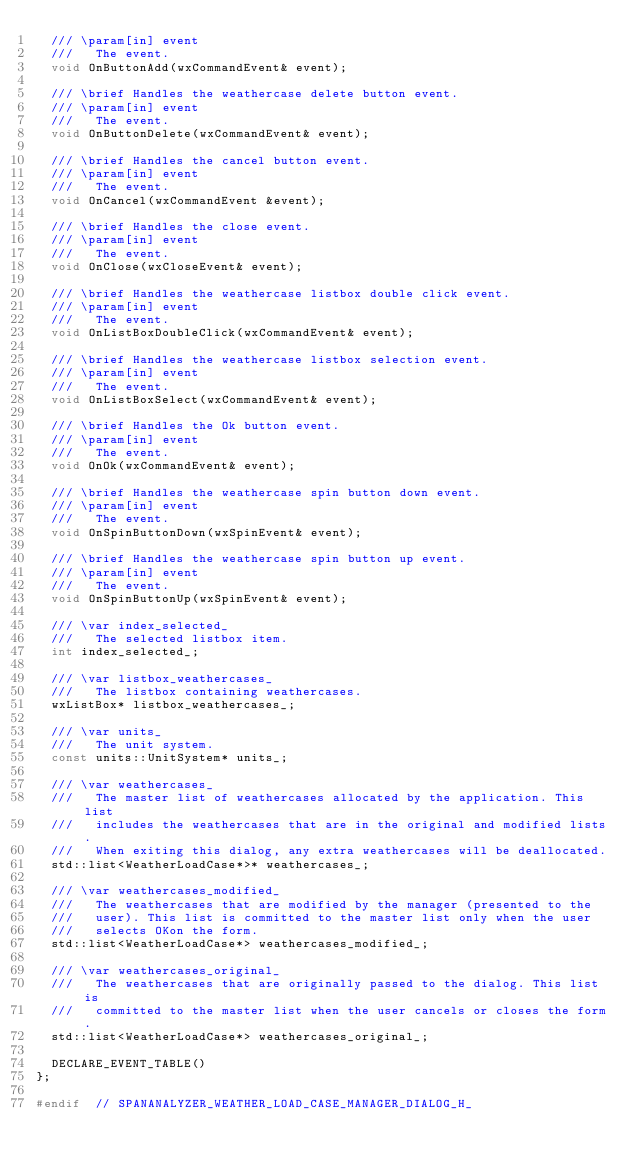<code> <loc_0><loc_0><loc_500><loc_500><_C_>  /// \param[in] event
  ///   The event.
  void OnButtonAdd(wxCommandEvent& event);

  /// \brief Handles the weathercase delete button event.
  /// \param[in] event
  ///   The event.
  void OnButtonDelete(wxCommandEvent& event);

  /// \brief Handles the cancel button event.
  /// \param[in] event
  ///   The event.
  void OnCancel(wxCommandEvent &event);

  /// \brief Handles the close event.
  /// \param[in] event
  ///   The event.
  void OnClose(wxCloseEvent& event);

  /// \brief Handles the weathercase listbox double click event.
  /// \param[in] event
  ///   The event.
  void OnListBoxDoubleClick(wxCommandEvent& event);

  /// \brief Handles the weathercase listbox selection event.
  /// \param[in] event
  ///   The event.
  void OnListBoxSelect(wxCommandEvent& event);

  /// \brief Handles the Ok button event.
  /// \param[in] event
  ///   The event.
  void OnOk(wxCommandEvent& event);

  /// \brief Handles the weathercase spin button down event.
  /// \param[in] event
  ///   The event.
  void OnSpinButtonDown(wxSpinEvent& event);

  /// \brief Handles the weathercase spin button up event.
  /// \param[in] event
  ///   The event.
  void OnSpinButtonUp(wxSpinEvent& event);

  /// \var index_selected_
  ///   The selected listbox item.
  int index_selected_;

  /// \var listbox_weathercases_
  ///   The listbox containing weathercases.
  wxListBox* listbox_weathercases_;

  /// \var units_
  ///   The unit system.
  const units::UnitSystem* units_;

  /// \var weathercases_
  ///   The master list of weathercases allocated by the application. This list
  ///   includes the weathercases that are in the original and modified lists.
  ///   When exiting this dialog, any extra weathercases will be deallocated.
  std::list<WeatherLoadCase*>* weathercases_;

  /// \var weathercases_modified_
  ///   The weathercases that are modified by the manager (presented to the
  ///   user). This list is committed to the master list only when the user
  ///   selects OKon the form.
  std::list<WeatherLoadCase*> weathercases_modified_;

  /// \var weathercases_original_
  ///   The weathercases that are originally passed to the dialog. This list is
  ///   committed to the master list when the user cancels or closes the form.
  std::list<WeatherLoadCase*> weathercases_original_;

  DECLARE_EVENT_TABLE()
};

#endif  // SPANANALYZER_WEATHER_LOAD_CASE_MANAGER_DIALOG_H_
</code> 